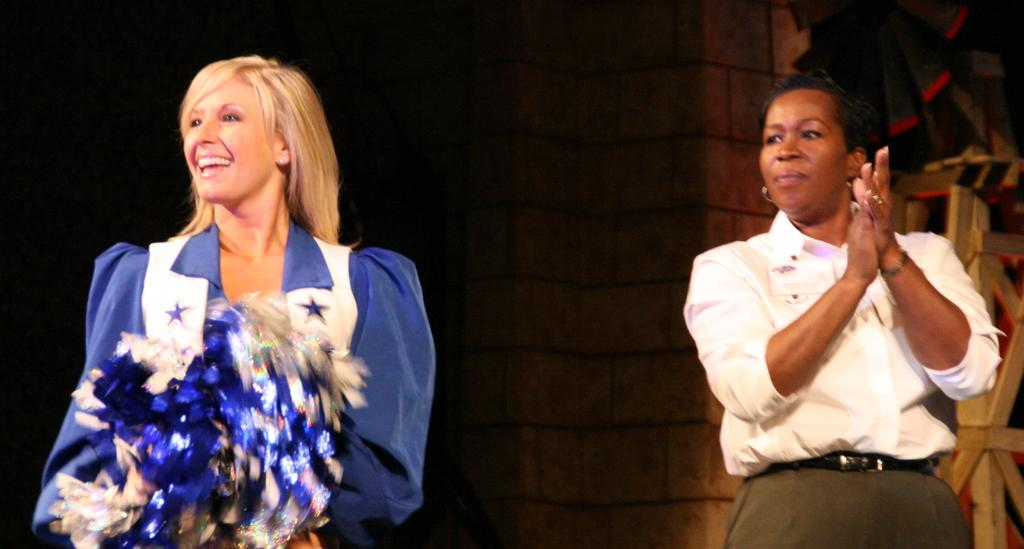How many people are in the image? There are two persons in the image. What are the persons doing in the image? The persons are standing and smiling. What can be seen in the background of the image? There is a wall in the background of the image. Can you see the moon in the image? No, the moon is not visible in the image. 